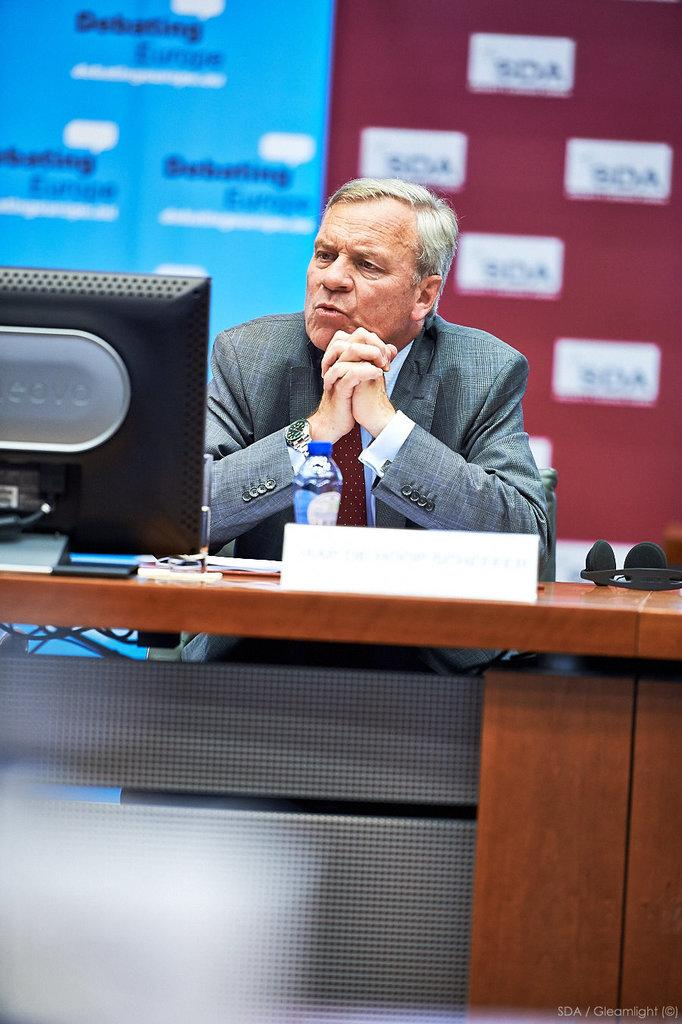What is the main subject in the foreground of the image? There is a man in the foreground of the image. What is the man doing in the image? The man is sitting in front of a table. What objects can be seen on the table? There is a bottle, a name board, papers, and a monitor on the table. What is visible in the background of the image? There is a banner wall in the background of the image. What type of ice can be seen melting on the monitor in the image? There is no ice present in the image, and the monitor is not related to any ice. Can you tell me how the man's memory is being tested in the image? There is no indication in the image that the man's memory is being tested, and no such activity is depicted. 